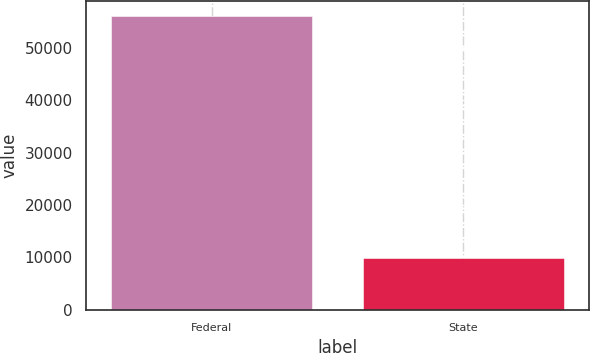Convert chart to OTSL. <chart><loc_0><loc_0><loc_500><loc_500><bar_chart><fcel>Federal<fcel>State<nl><fcel>56060<fcel>9948<nl></chart> 